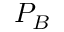<formula> <loc_0><loc_0><loc_500><loc_500>P _ { B }</formula> 